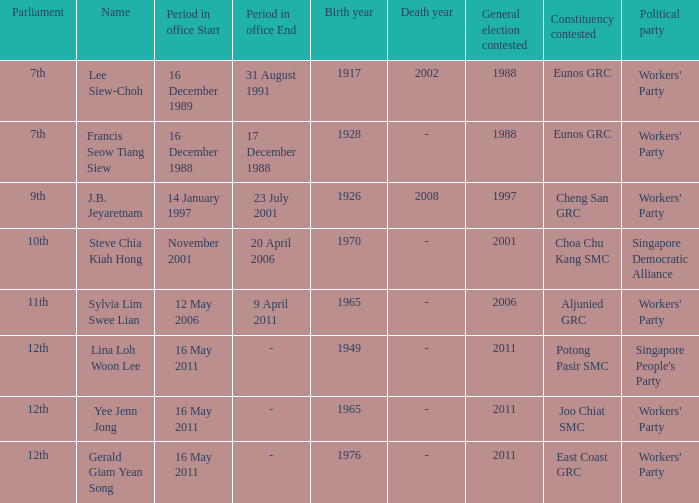Could you parse the entire table? {'header': ['Parliament', 'Name', 'Period in office Start', 'Period in office End', 'Birth year', 'Death year', 'General election contested', 'Constituency contested', 'Political party'], 'rows': [['7th', 'Lee Siew-Choh', '16 December 1989', '31 August 1991', '1917', '2002', '1988', 'Eunos GRC', "Workers' Party"], ['7th', 'Francis Seow Tiang Siew', '16 December 1988', '17 December 1988', '1928', '-', '1988', 'Eunos GRC', "Workers' Party"], ['9th', 'J.B. Jeyaretnam', '14 January 1997', '23 July 2001', '1926', '2008', '1997', 'Cheng San GRC', "Workers' Party"], ['10th', 'Steve Chia Kiah Hong', 'November 2001', '20 April 2006', '1970', '-', '2001', 'Choa Chu Kang SMC', 'Singapore Democratic Alliance'], ['11th', 'Sylvia Lim Swee Lian', '12 May 2006', '9 April 2011', '1965', '-', '2006', 'Aljunied GRC', "Workers' Party"], ['12th', 'Lina Loh Woon Lee', '16 May 2011', '-', '1949', '-', '2011', 'Potong Pasir SMC', "Singapore People's Party"], ['12th', 'Yee Jenn Jong', '16 May 2011', '-', '1965', '-', '2011', 'Joo Chiat SMC', "Workers' Party"], ['12th', 'Gerald Giam Yean Song', '16 May 2011', '-', '1976', '-', '2011', 'East Coast GRC', "Workers' Party"]]} What period were conscituency contested is aljunied grc? 12 May2006– 9 April 2011. 